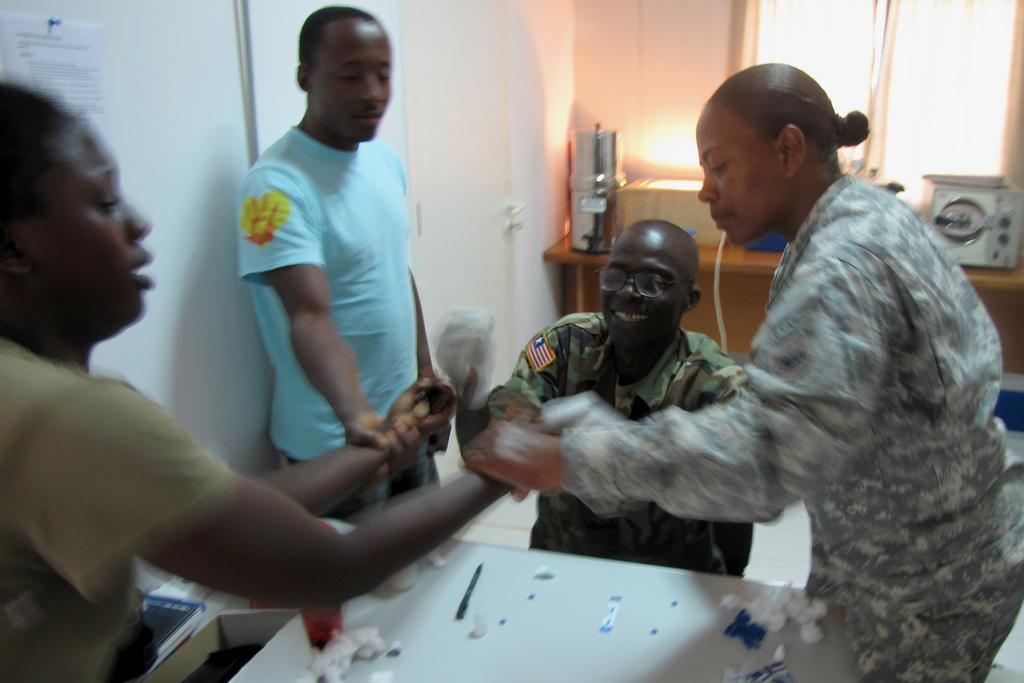How many people are in the image? There is a group of people in the image, but the exact number cannot be determined from the provided facts. What type of furniture is visible in the image? There are tables in the image. What else can be seen in the image besides the people and tables? There are objects in the image. What can be seen in the background of the image? There is a wall and a window in the background of the image. What type of crack is visible on the wall in the image? There is no crack visible on the wall in the image. Can you tell me how many dogs are present in the image? There are no dogs present in the image. What type of quince is being used as a decoration in the image? There is no quince present in the image. 